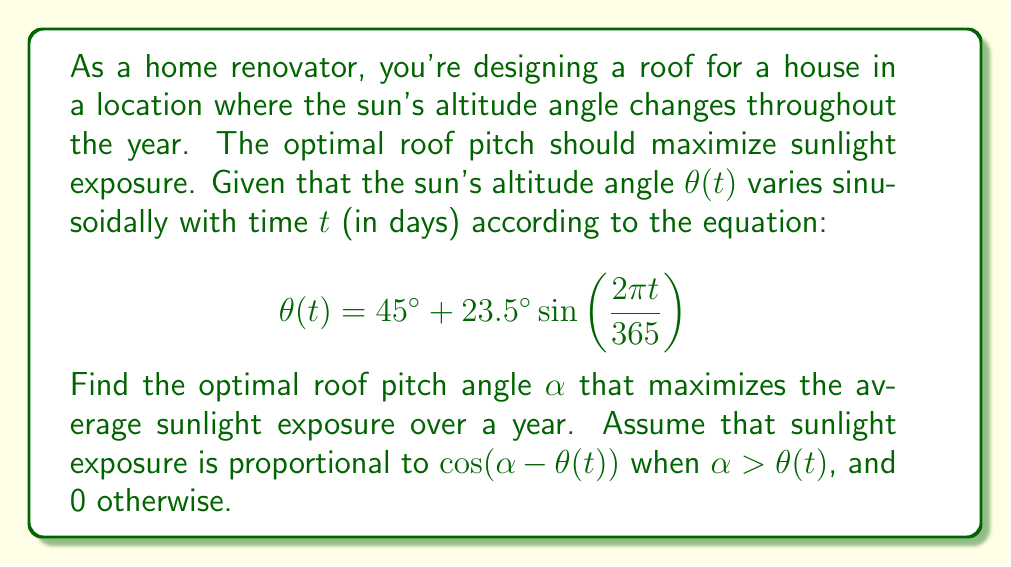Solve this math problem. To solve this problem, we need to maximize the average sunlight exposure over a year. Let's break it down step-by-step:

1) The sunlight exposure function $E(\alpha, t)$ can be written as:
   $$E(\alpha, t) = \max(0, \cos(\alpha - \theta(t)))$$

2) We want to maximize the average exposure over a year:
   $$\bar{E}(\alpha) = \frac{1}{365} \int_0^{365} E(\alpha, t) dt$$

3) To simplify, let's assume $\alpha$ is always greater than $\theta(t)$. This is reasonable for most roof pitches. Then:
   $$\bar{E}(\alpha) = \frac{1}{365} \int_0^{365} \cos(\alpha - \theta(t)) dt$$

4) Substituting $\theta(t)$ and expanding:
   $$\bar{E}(\alpha) = \frac{1}{365} \int_0^{365} \cos\left(\alpha - 45^\circ - 23.5^\circ \sin\left(\frac{2\pi t}{365}\right)\right) dt$$

5) This integral is complex, but we can simplify it using the following approximation:
   $$\cos(A - B \sin(x)) \approx \cos(A) + B \sin(A) \sin(x)$$

6) Applying this approximation:
   $$\bar{E}(\alpha) \approx \cos(\alpha - 45^\circ) + 23.5^\circ \sin(\alpha - 45^\circ) \cdot \frac{1}{365} \int_0^{365} \sin\left(\frac{2\pi t}{365}\right) dt$$

7) The integral of sine over a full period is zero, so:
   $$\bar{E}(\alpha) \approx \cos(\alpha - 45^\circ)$$

8) To maximize this, we set $\alpha - 45^\circ = 0$, or $\alpha = 45^\circ$

Therefore, the optimal roof pitch angle is approximately 45°.
Answer: The optimal roof pitch angle $\alpha$ is approximately $45^\circ$. 